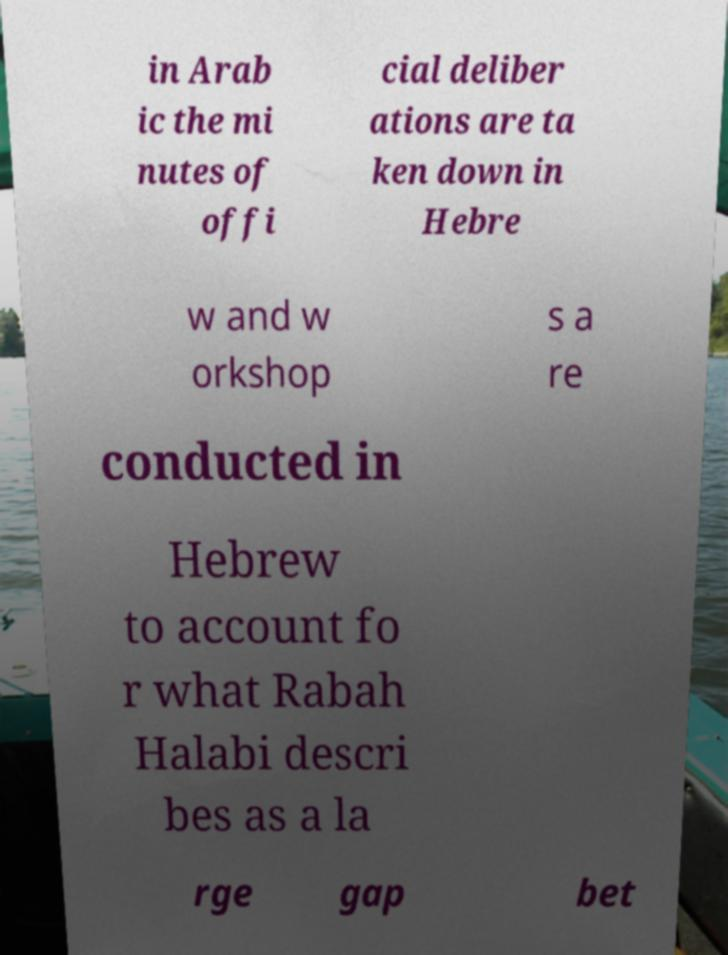Could you extract and type out the text from this image? in Arab ic the mi nutes of offi cial deliber ations are ta ken down in Hebre w and w orkshop s a re conducted in Hebrew to account fo r what Rabah Halabi descri bes as a la rge gap bet 